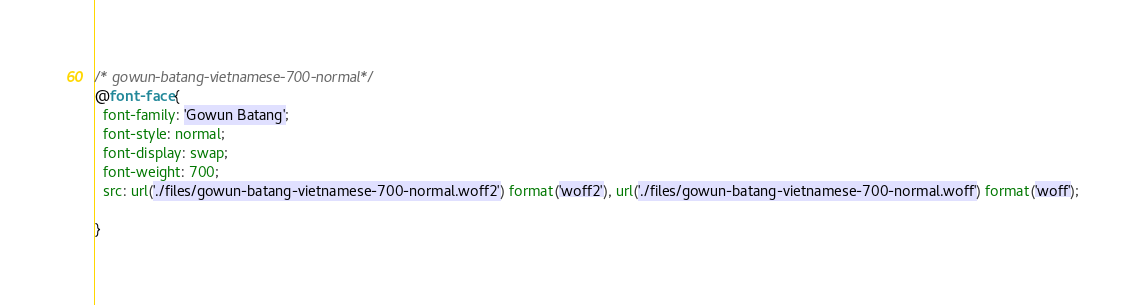Convert code to text. <code><loc_0><loc_0><loc_500><loc_500><_CSS_>/* gowun-batang-vietnamese-700-normal*/
@font-face {
  font-family: 'Gowun Batang';
  font-style: normal;
  font-display: swap;
  font-weight: 700;
  src: url('./files/gowun-batang-vietnamese-700-normal.woff2') format('woff2'), url('./files/gowun-batang-vietnamese-700-normal.woff') format('woff');
  
}
</code> 